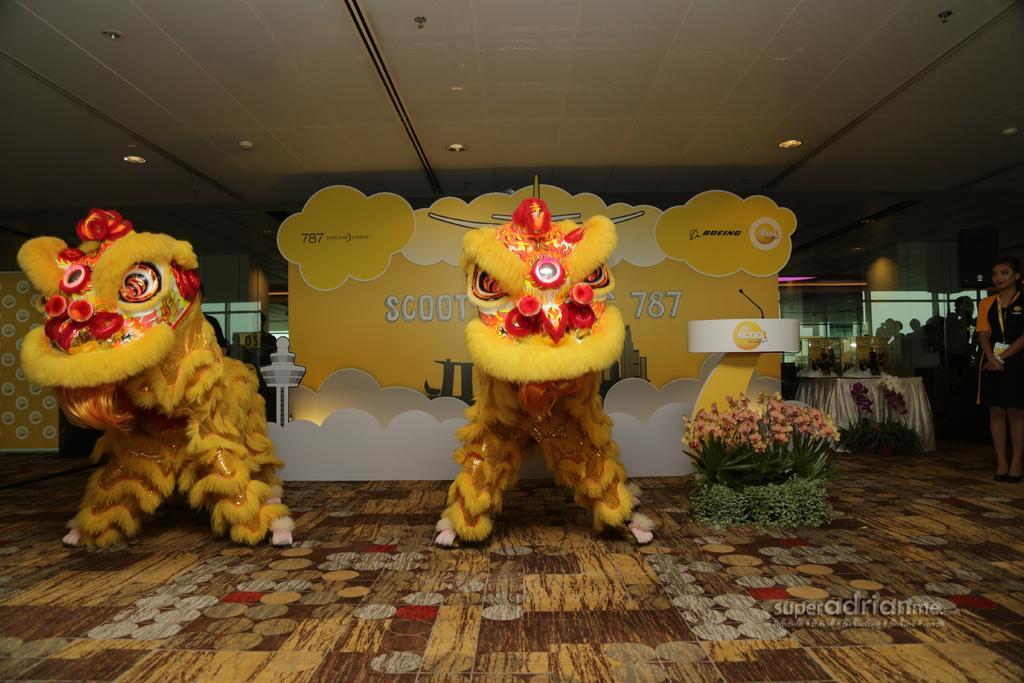In one or two sentences, can you explain what this image depicts? In this image at the center there are two animals. At the background there is a banner. In front of that there is a plant. At the right side of the image there is a table and on top of it there are few objects. There is a person standing on the floor. On top of the roof there are fall ceiling lights. 